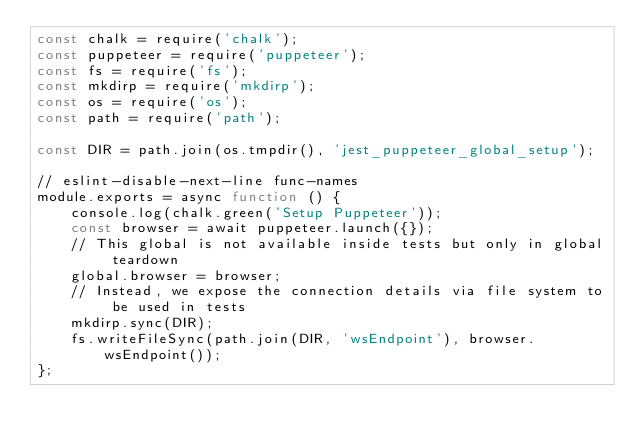Convert code to text. <code><loc_0><loc_0><loc_500><loc_500><_JavaScript_>const chalk = require('chalk');
const puppeteer = require('puppeteer');
const fs = require('fs');
const mkdirp = require('mkdirp');
const os = require('os');
const path = require('path');

const DIR = path.join(os.tmpdir(), 'jest_puppeteer_global_setup');

// eslint-disable-next-line func-names
module.exports = async function () {
    console.log(chalk.green('Setup Puppeteer'));
    const browser = await puppeteer.launch({});
    // This global is not available inside tests but only in global teardown
    global.browser = browser;
    // Instead, we expose the connection details via file system to be used in tests
    mkdirp.sync(DIR);
    fs.writeFileSync(path.join(DIR, 'wsEndpoint'), browser.wsEndpoint());
};
</code> 